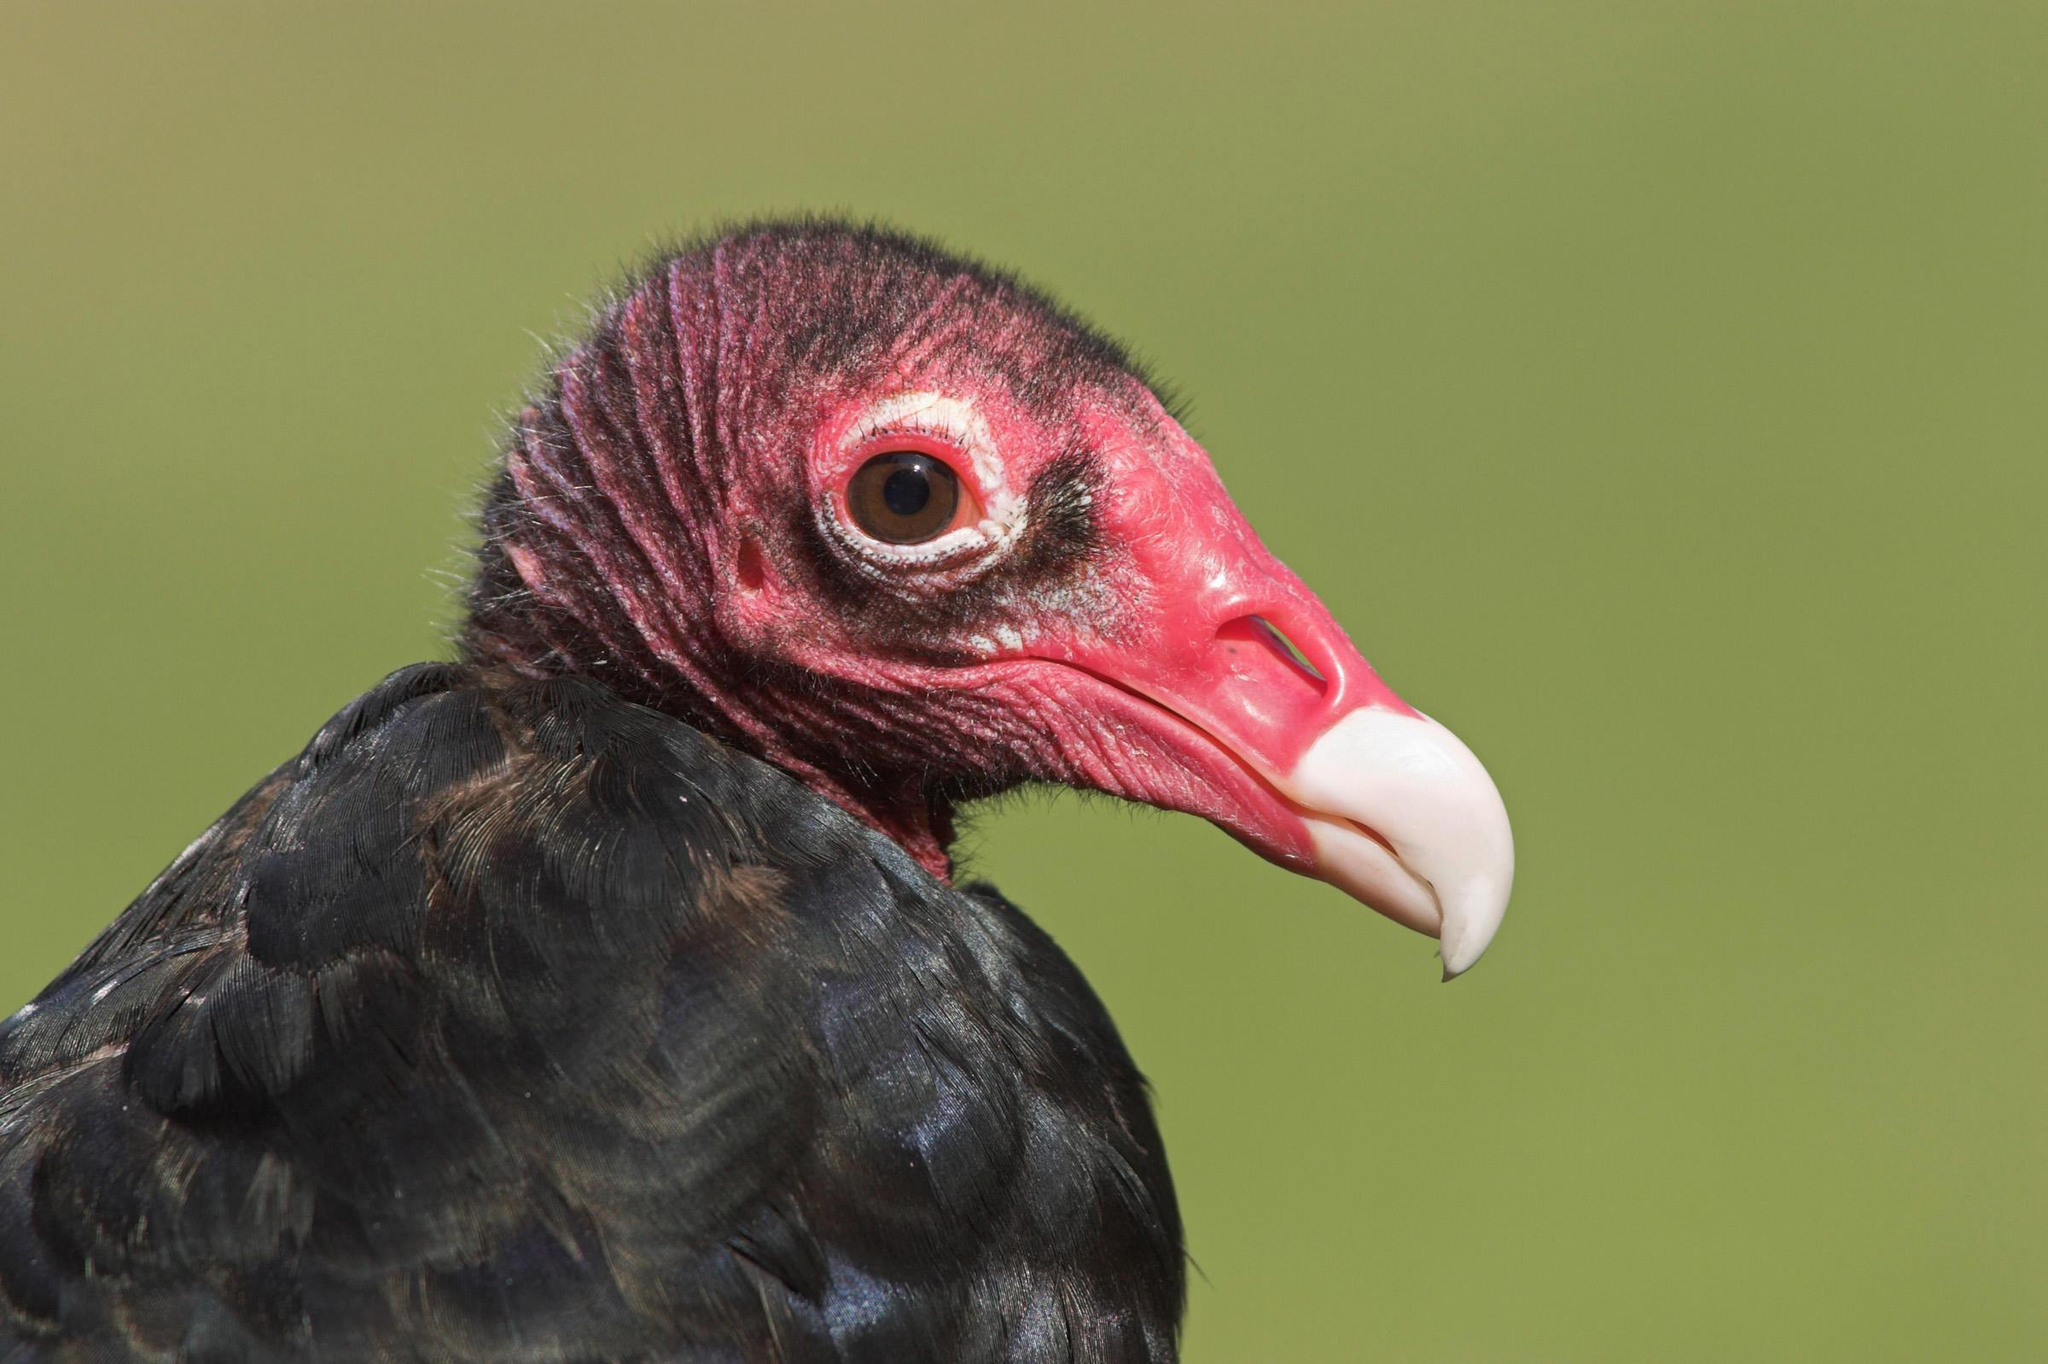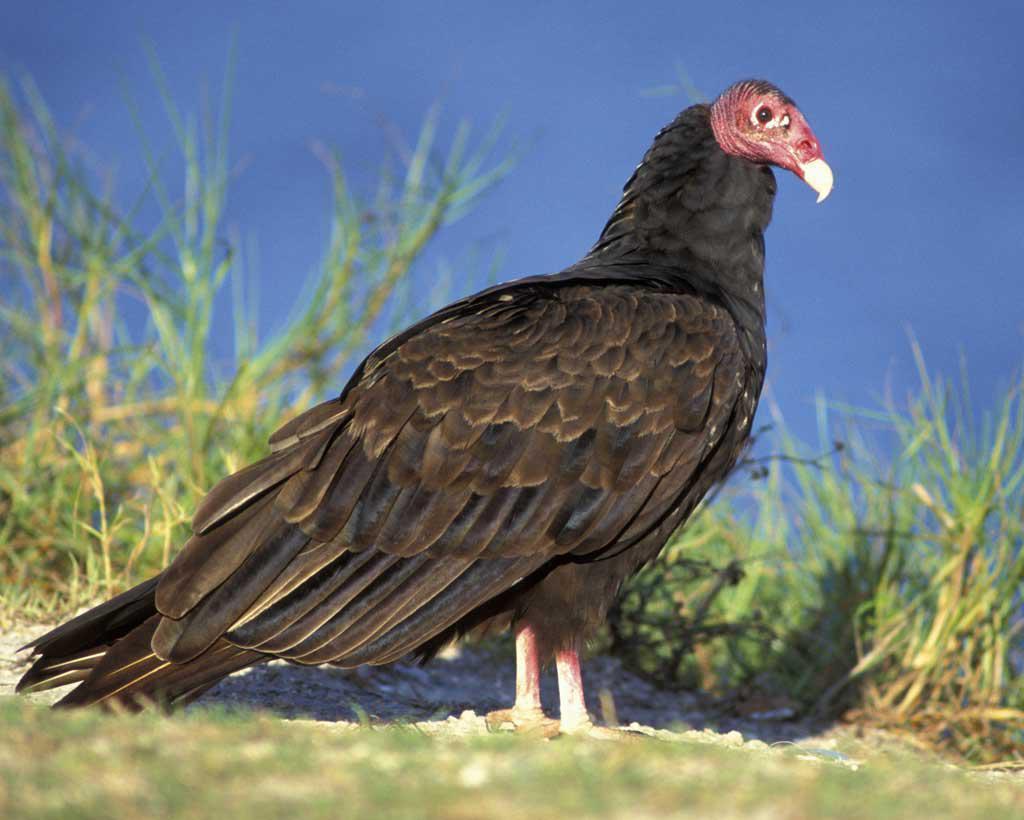The first image is the image on the left, the second image is the image on the right. Evaluate the accuracy of this statement regarding the images: "Both birds are facing the same direction.". Is it true? Answer yes or no. Yes. 